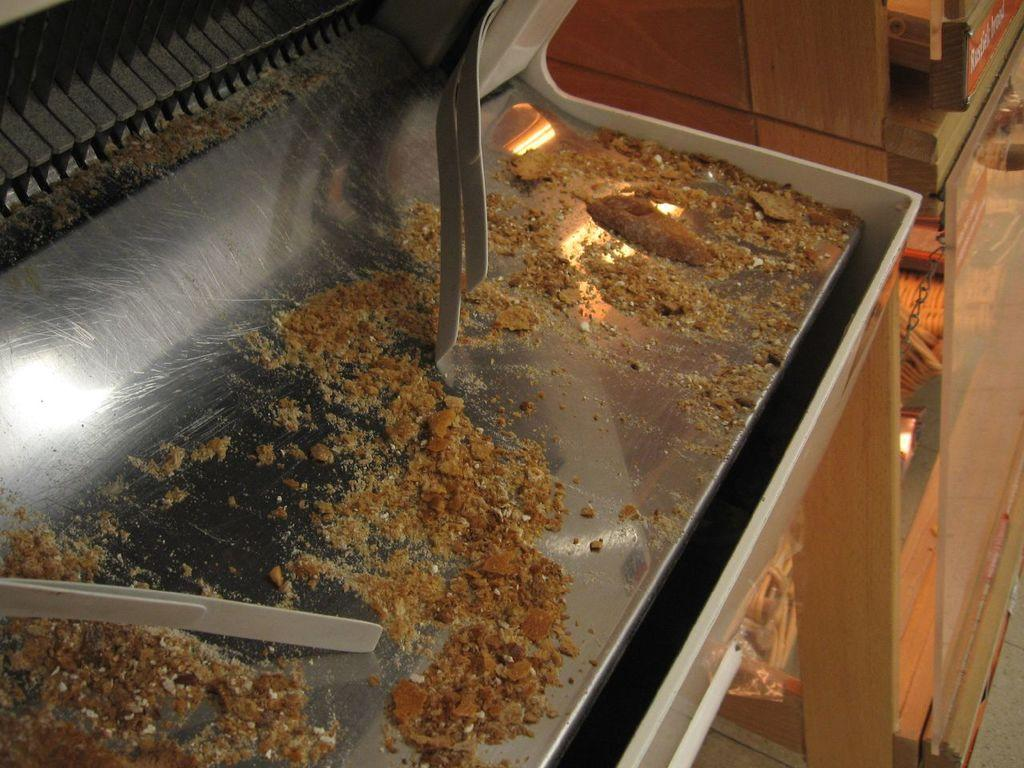What is the main subject of the image? The main subject of the image is food on a machine. Can you describe the other objects in the image? There is a cupboard with objects in the image. What type of stew is being prepared in the image? There is no stew being prepared in the image; it only shows food on a machine and a cupboard with objects. How many cattle can be seen in the image? There are no cattle present in the image. 